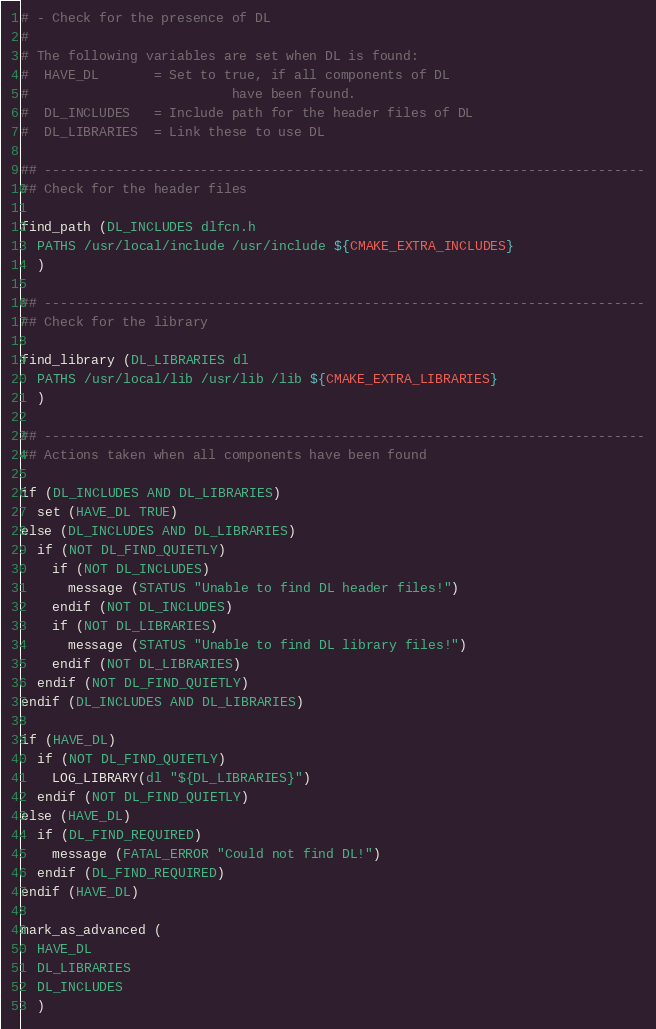Convert code to text. <code><loc_0><loc_0><loc_500><loc_500><_CMake_># - Check for the presence of DL
#
# The following variables are set when DL is found:
#  HAVE_DL       = Set to true, if all components of DL
#                          have been found.
#  DL_INCLUDES   = Include path for the header files of DL
#  DL_LIBRARIES  = Link these to use DL

## -----------------------------------------------------------------------------
## Check for the header files

find_path (DL_INCLUDES dlfcn.h
  PATHS /usr/local/include /usr/include ${CMAKE_EXTRA_INCLUDES}
  )

## -----------------------------------------------------------------------------
## Check for the library

find_library (DL_LIBRARIES dl
  PATHS /usr/local/lib /usr/lib /lib ${CMAKE_EXTRA_LIBRARIES}
  )

## -----------------------------------------------------------------------------
## Actions taken when all components have been found

if (DL_INCLUDES AND DL_LIBRARIES)
  set (HAVE_DL TRUE)
else (DL_INCLUDES AND DL_LIBRARIES)
  if (NOT DL_FIND_QUIETLY)
    if (NOT DL_INCLUDES)
      message (STATUS "Unable to find DL header files!")
    endif (NOT DL_INCLUDES)
    if (NOT DL_LIBRARIES)
      message (STATUS "Unable to find DL library files!")
    endif (NOT DL_LIBRARIES)
  endif (NOT DL_FIND_QUIETLY)
endif (DL_INCLUDES AND DL_LIBRARIES)

if (HAVE_DL)
  if (NOT DL_FIND_QUIETLY)
    LOG_LIBRARY(dl "${DL_LIBRARIES}")
  endif (NOT DL_FIND_QUIETLY)
else (HAVE_DL)
  if (DL_FIND_REQUIRED)
    message (FATAL_ERROR "Could not find DL!")
  endif (DL_FIND_REQUIRED)
endif (HAVE_DL)

mark_as_advanced (
  HAVE_DL
  DL_LIBRARIES
  DL_INCLUDES
  )
</code> 